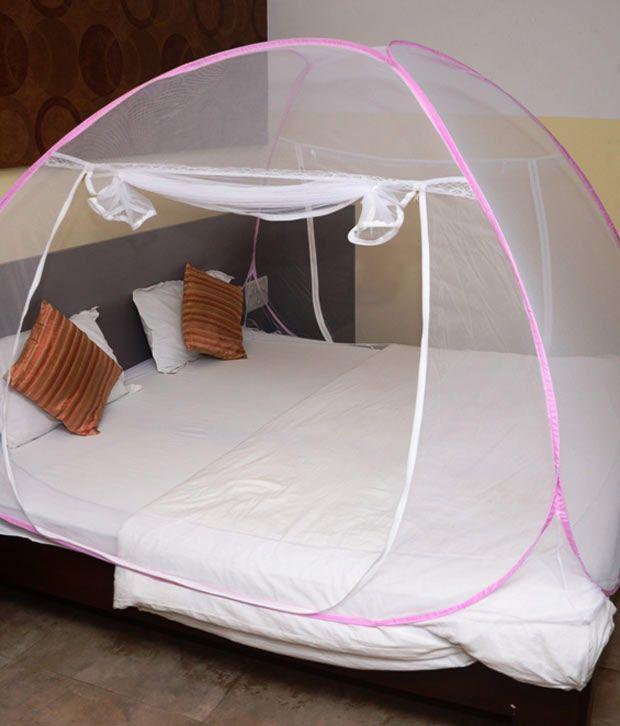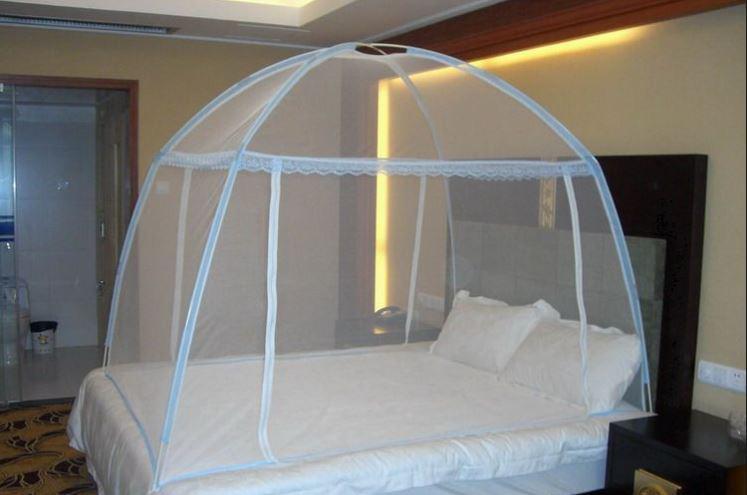The first image is the image on the left, the second image is the image on the right. Assess this claim about the two images: "The left image shows a rounded dome bed enclosure.". Correct or not? Answer yes or no. Yes. 